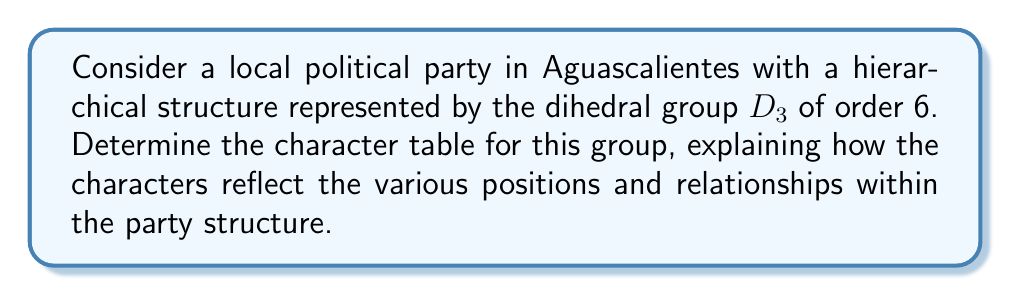Give your solution to this math problem. To determine the character table for the dihedral group $D_3$, which represents our local political party structure, we'll follow these steps:

1) First, recall that $D_3$ has 6 elements: $\{e, r, r^2, s, sr, sr^2\}$, where $e$ is the identity, $r$ is a rotation by 120°, and $s$ is a reflection.

2) The conjugacy classes of $D_3$ are:
   $\{e\}$, $\{r, r^2\}$, and $\{s, sr, sr^2\}$

3) The number of irreducible representations equals the number of conjugacy classes, so we have 3 irreducible representations.

4) We know that the sum of the squares of the dimensions of the irreducible representations must equal the order of the group:
   $d_1^2 + d_2^2 + d_3^2 = 6$

5) The only solution for this is $1^2 + 1^2 + 2^2 = 6$, so we have two 1-dimensional representations and one 2-dimensional representation.

6) The first row of the character table is always the trivial representation, with all characters equal to 1.

7) The second row corresponds to the sign representation. The character is 1 for elements in the rotational subgroup and -1 for reflections.

8) For the 2-dimensional representation, we can use the fact that the sum of the characters in each column must be zero (orthogonality of characters):

   For the $\{r, r^2\}$ class: $1 + 1 + x = 0$, so $x = -2$
   For the $\{s, sr, sr^2\}$ class: $1 - 1 + y = 0$, so $y = 0$

9) The resulting character table is:

   $$\begin{array}{c|ccc}
      D_3 & \{e\} & \{r, r^2\} & \{s, sr, sr^2\} \\
      \hline
      \chi_1 & 1 & 1 & 1 \\
      \chi_2 & 1 & 1 & -1 \\
      \chi_3 & 2 & -1 & 0
   \end{array}$$

In the context of our local political party:
- $\chi_1$ represents the trivial representation, where all members are treated equally.
- $\chi_2$ distinguishes between the core leadership (rotations) and the auxiliary positions (reflections).
- $\chi_3$ provides a more nuanced view of the party structure, differentiating between the party leader (identity), core members (rotations), and auxiliary positions (reflections).
Answer: $$\begin{array}{c|ccc}
   D_3 & \{e\} & \{r, r^2\} & \{s, sr, sr^2\} \\
   \hline
   \chi_1 & 1 & 1 & 1 \\
   \chi_2 & 1 & 1 & -1 \\
   \chi_3 & 2 & -1 & 0
\end{array}$$ 